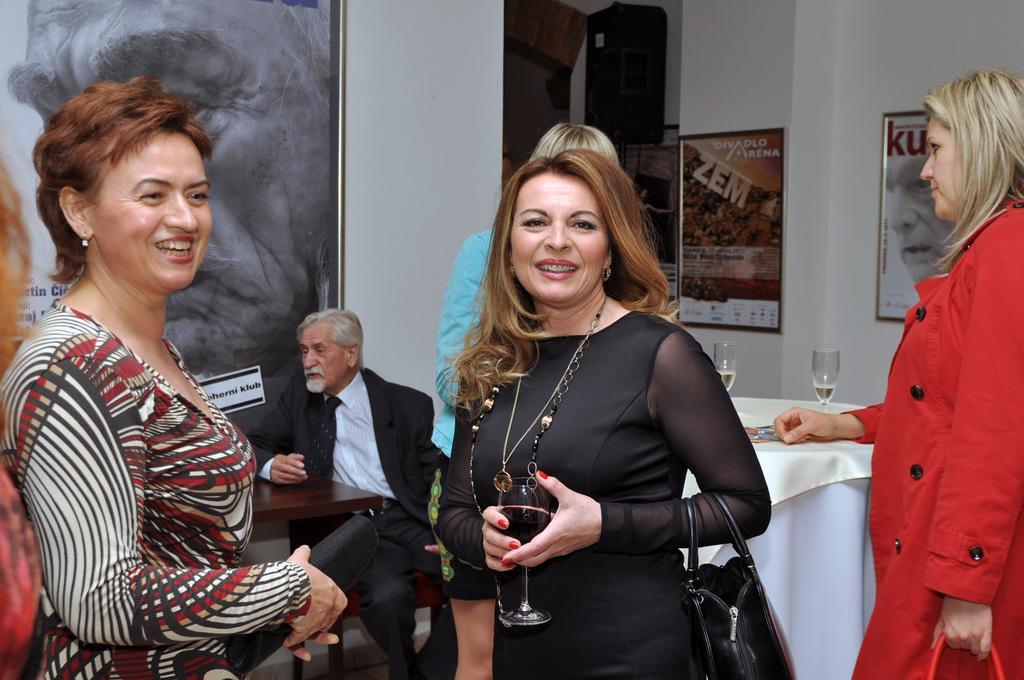Can you describe this image briefly? As we can see in the image there is a white color wall, photo frame, few people over here and there is a table. On table there are glasses. 